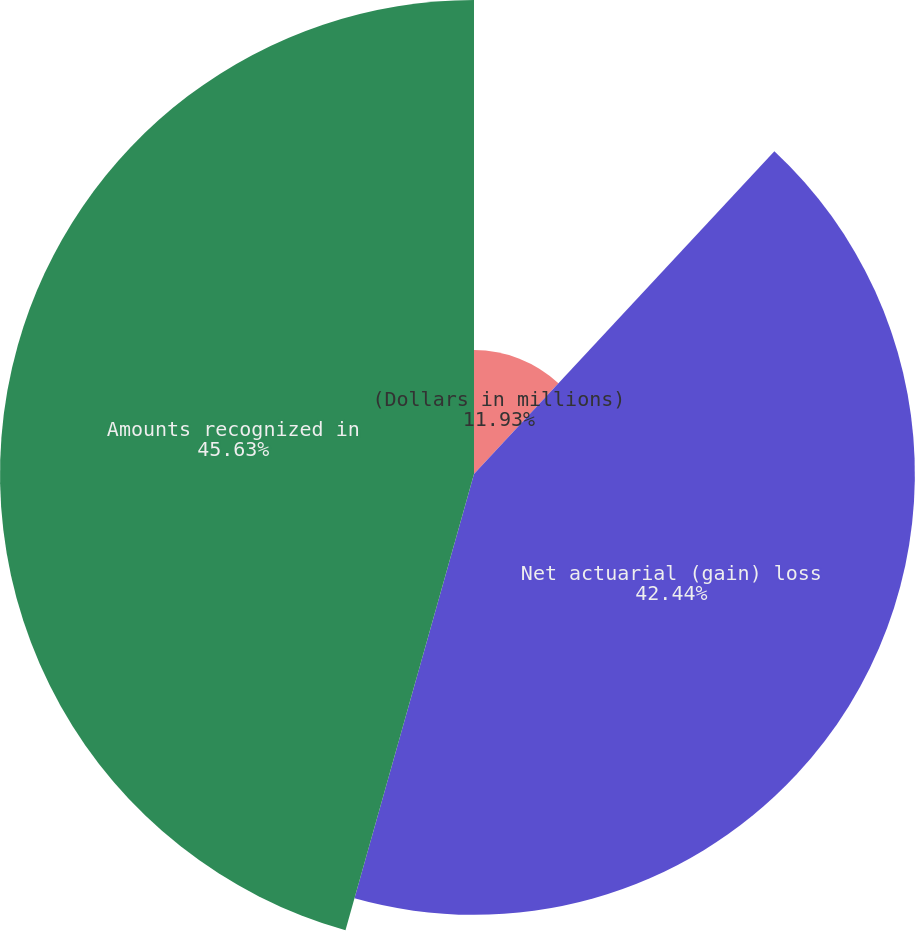Convert chart to OTSL. <chart><loc_0><loc_0><loc_500><loc_500><pie_chart><fcel>(Dollars in millions)<fcel>Net actuarial (gain) loss<fcel>Amounts recognized in<nl><fcel>11.93%<fcel>42.44%<fcel>45.63%<nl></chart> 